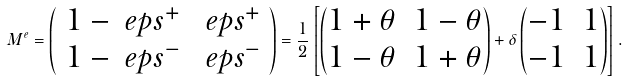Convert formula to latex. <formula><loc_0><loc_0><loc_500><loc_500>M ^ { e } = \left ( \begin{array} { c c } 1 - \ e p s ^ { + } & \ e p s ^ { + } \\ 1 - \ e p s ^ { - } & \ e p s ^ { - } \end{array} \right ) = \frac { 1 } { 2 } \left [ \left ( \begin{matrix} 1 + \theta & 1 - \theta \\ 1 - \theta & 1 + \theta \end{matrix} \right ) + \delta \left ( \begin{matrix} - 1 & 1 \\ - 1 & 1 \end{matrix} \right ) \right ] .</formula> 